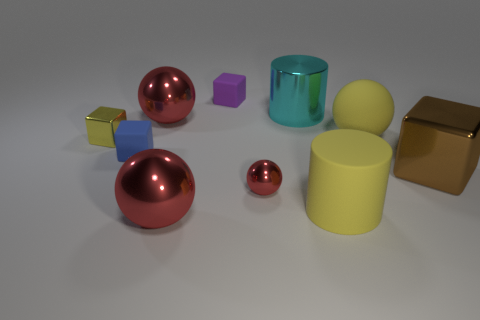Subtract all red cubes. How many red balls are left? 3 Subtract 1 balls. How many balls are left? 3 Subtract all yellow spheres. Subtract all gray cylinders. How many spheres are left? 3 Subtract all spheres. How many objects are left? 6 Add 8 blue objects. How many blue objects are left? 9 Add 5 large brown rubber blocks. How many large brown rubber blocks exist? 5 Subtract 1 yellow cylinders. How many objects are left? 9 Subtract all rubber blocks. Subtract all yellow shiny things. How many objects are left? 7 